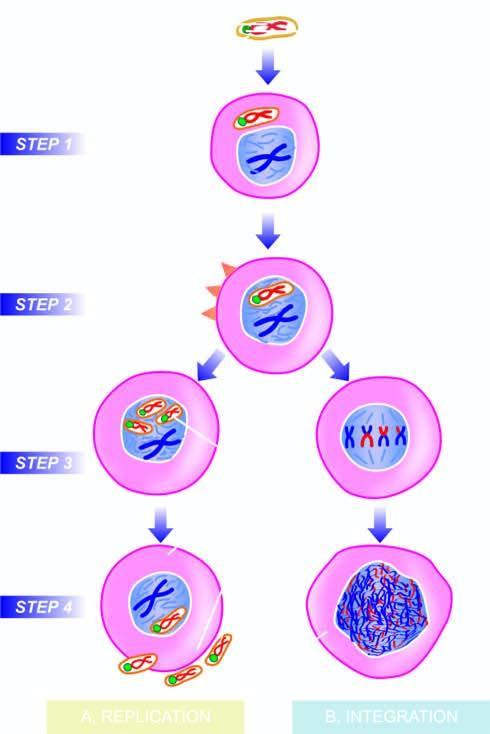what are the new virions released, accompanied by?
Answer the question using a single word or phrase. Host cell lysis 